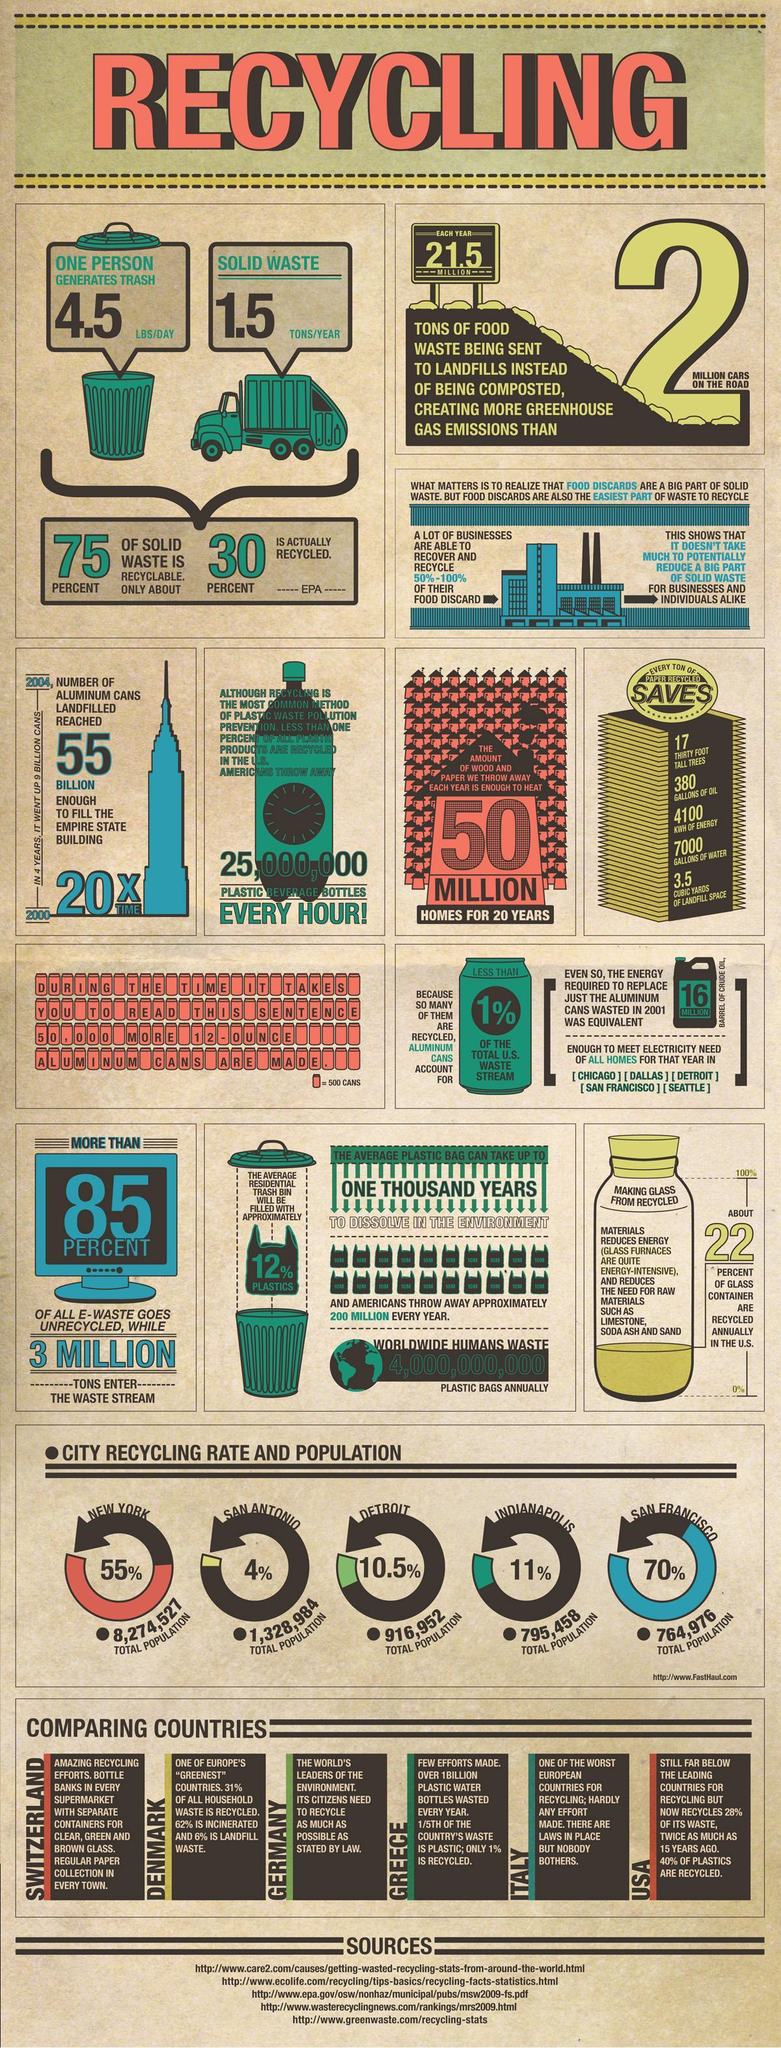What percentage of waste is still available for recycling?
Answer the question with a short phrase. 40% Which three countries have to improve their waste management efforts? Greece, Italy, USA Which city has the highest recycling rate New York, Detroit, or San Francisco ? San Francisco Which city has the highest total population, Detroit, San Antonio, or New York? New York What is the difference in percentage of recycling between San Francisco and Indianapolis? 59% Which three countries in the world are good at waste management? Switzerland, Denmark, Germany How much more population does New York have in comparison to San Antonio? 6,945,543 Which city has the second highest population and the least percentage of recycling? San Antonio 